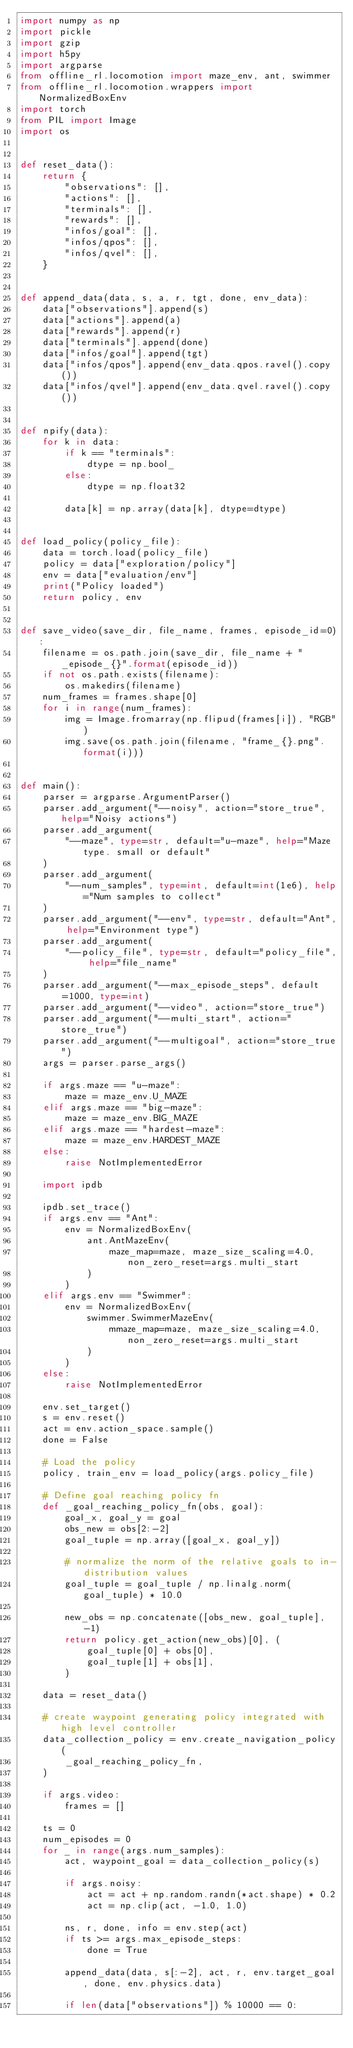Convert code to text. <code><loc_0><loc_0><loc_500><loc_500><_Python_>import numpy as np
import pickle
import gzip
import h5py
import argparse
from offline_rl.locomotion import maze_env, ant, swimmer
from offline_rl.locomotion.wrappers import NormalizedBoxEnv
import torch
from PIL import Image
import os


def reset_data():
    return {
        "observations": [],
        "actions": [],
        "terminals": [],
        "rewards": [],
        "infos/goal": [],
        "infos/qpos": [],
        "infos/qvel": [],
    }


def append_data(data, s, a, r, tgt, done, env_data):
    data["observations"].append(s)
    data["actions"].append(a)
    data["rewards"].append(r)
    data["terminals"].append(done)
    data["infos/goal"].append(tgt)
    data["infos/qpos"].append(env_data.qpos.ravel().copy())
    data["infos/qvel"].append(env_data.qvel.ravel().copy())


def npify(data):
    for k in data:
        if k == "terminals":
            dtype = np.bool_
        else:
            dtype = np.float32

        data[k] = np.array(data[k], dtype=dtype)


def load_policy(policy_file):
    data = torch.load(policy_file)
    policy = data["exploration/policy"]
    env = data["evaluation/env"]
    print("Policy loaded")
    return policy, env


def save_video(save_dir, file_name, frames, episode_id=0):
    filename = os.path.join(save_dir, file_name + "_episode_{}".format(episode_id))
    if not os.path.exists(filename):
        os.makedirs(filename)
    num_frames = frames.shape[0]
    for i in range(num_frames):
        img = Image.fromarray(np.flipud(frames[i]), "RGB")
        img.save(os.path.join(filename, "frame_{}.png".format(i)))


def main():
    parser = argparse.ArgumentParser()
    parser.add_argument("--noisy", action="store_true", help="Noisy actions")
    parser.add_argument(
        "--maze", type=str, default="u-maze", help="Maze type. small or default"
    )
    parser.add_argument(
        "--num_samples", type=int, default=int(1e6), help="Num samples to collect"
    )
    parser.add_argument("--env", type=str, default="Ant", help="Environment type")
    parser.add_argument(
        "--policy_file", type=str, default="policy_file", help="file_name"
    )
    parser.add_argument("--max_episode_steps", default=1000, type=int)
    parser.add_argument("--video", action="store_true")
    parser.add_argument("--multi_start", action="store_true")
    parser.add_argument("--multigoal", action="store_true")
    args = parser.parse_args()

    if args.maze == "u-maze":
        maze = maze_env.U_MAZE
    elif args.maze == "big-maze":
        maze = maze_env.BIG_MAZE
    elif args.maze == "hardest-maze":
        maze = maze_env.HARDEST_MAZE
    else:
        raise NotImplementedError

    import ipdb

    ipdb.set_trace()
    if args.env == "Ant":
        env = NormalizedBoxEnv(
            ant.AntMazeEnv(
                maze_map=maze, maze_size_scaling=4.0, non_zero_reset=args.multi_start
            )
        )
    elif args.env == "Swimmer":
        env = NormalizedBoxEnv(
            swimmer.SwimmerMazeEnv(
                mmaze_map=maze, maze_size_scaling=4.0, non_zero_reset=args.multi_start
            )
        )
    else:
        raise NotImplementedError

    env.set_target()
    s = env.reset()
    act = env.action_space.sample()
    done = False

    # Load the policy
    policy, train_env = load_policy(args.policy_file)

    # Define goal reaching policy fn
    def _goal_reaching_policy_fn(obs, goal):
        goal_x, goal_y = goal
        obs_new = obs[2:-2]
        goal_tuple = np.array([goal_x, goal_y])

        # normalize the norm of the relative goals to in-distribution values
        goal_tuple = goal_tuple / np.linalg.norm(goal_tuple) * 10.0

        new_obs = np.concatenate([obs_new, goal_tuple], -1)
        return policy.get_action(new_obs)[0], (
            goal_tuple[0] + obs[0],
            goal_tuple[1] + obs[1],
        )

    data = reset_data()

    # create waypoint generating policy integrated with high level controller
    data_collection_policy = env.create_navigation_policy(
        _goal_reaching_policy_fn,
    )

    if args.video:
        frames = []

    ts = 0
    num_episodes = 0
    for _ in range(args.num_samples):
        act, waypoint_goal = data_collection_policy(s)

        if args.noisy:
            act = act + np.random.randn(*act.shape) * 0.2
            act = np.clip(act, -1.0, 1.0)

        ns, r, done, info = env.step(act)
        if ts >= args.max_episode_steps:
            done = True

        append_data(data, s[:-2], act, r, env.target_goal, done, env.physics.data)

        if len(data["observations"]) % 10000 == 0:</code> 